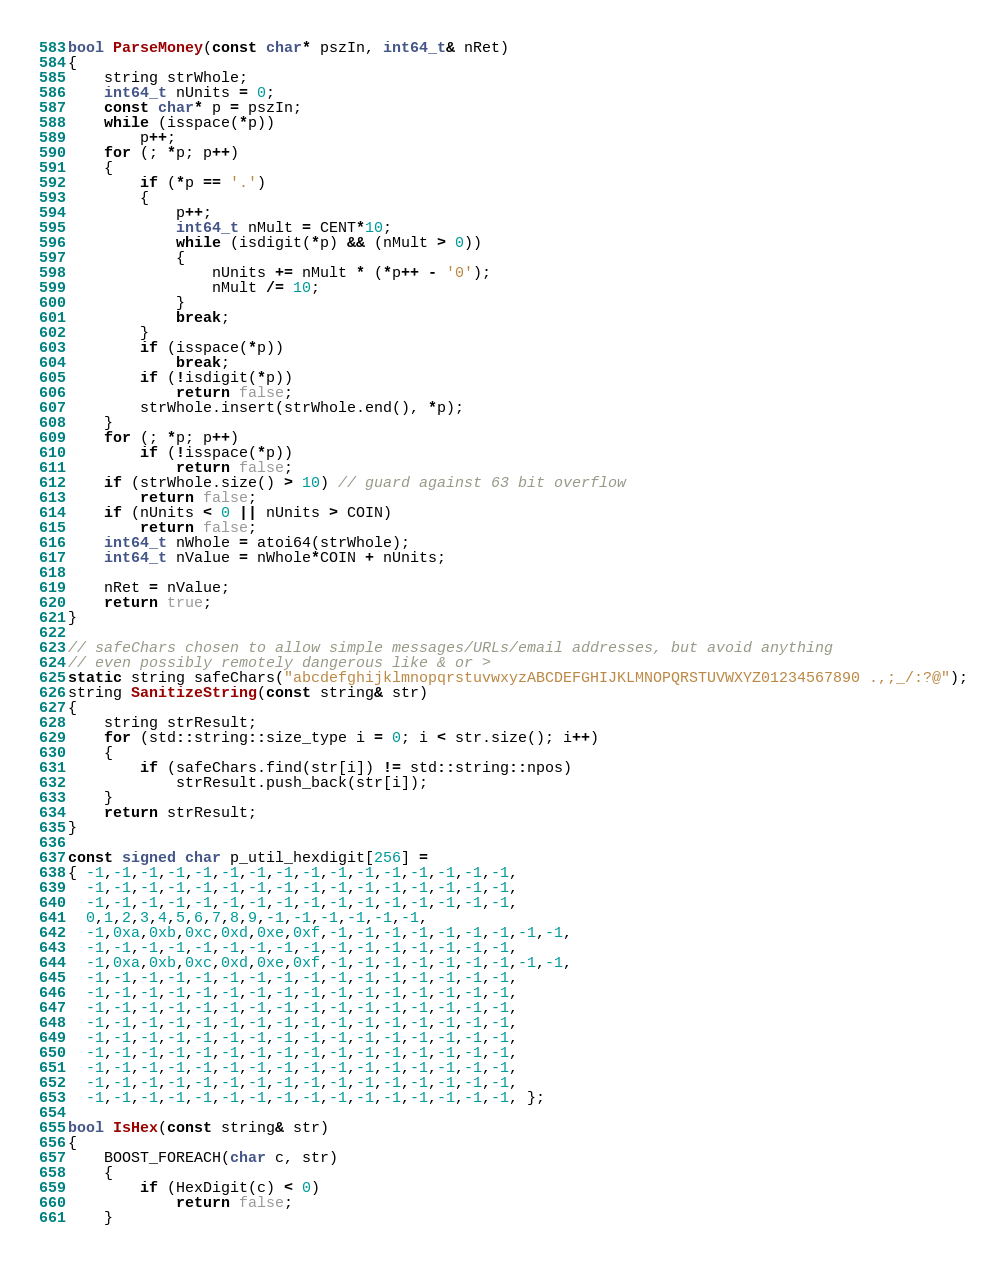Convert code to text. <code><loc_0><loc_0><loc_500><loc_500><_C++_>
bool ParseMoney(const char* pszIn, int64_t& nRet)
{
    string strWhole;
    int64_t nUnits = 0;
    const char* p = pszIn;
    while (isspace(*p))
        p++;
    for (; *p; p++)
    {
        if (*p == '.')
        {
            p++;
            int64_t nMult = CENT*10;
            while (isdigit(*p) && (nMult > 0))
            {
                nUnits += nMult * (*p++ - '0');
                nMult /= 10;
            }
            break;
        }
        if (isspace(*p))
            break;
        if (!isdigit(*p))
            return false;
        strWhole.insert(strWhole.end(), *p);
    }
    for (; *p; p++)
        if (!isspace(*p))
            return false;
    if (strWhole.size() > 10) // guard against 63 bit overflow
        return false;
    if (nUnits < 0 || nUnits > COIN)
        return false;
    int64_t nWhole = atoi64(strWhole);
    int64_t nValue = nWhole*COIN + nUnits;

    nRet = nValue;
    return true;
}

// safeChars chosen to allow simple messages/URLs/email addresses, but avoid anything
// even possibly remotely dangerous like & or >
static string safeChars("abcdefghijklmnopqrstuvwxyzABCDEFGHIJKLMNOPQRSTUVWXYZ01234567890 .,;_/:?@");
string SanitizeString(const string& str)
{
    string strResult;
    for (std::string::size_type i = 0; i < str.size(); i++)
    {
        if (safeChars.find(str[i]) != std::string::npos)
            strResult.push_back(str[i]);
    }
    return strResult;
}

const signed char p_util_hexdigit[256] =
{ -1,-1,-1,-1,-1,-1,-1,-1,-1,-1,-1,-1,-1,-1,-1,-1,
  -1,-1,-1,-1,-1,-1,-1,-1,-1,-1,-1,-1,-1,-1,-1,-1,
  -1,-1,-1,-1,-1,-1,-1,-1,-1,-1,-1,-1,-1,-1,-1,-1,
  0,1,2,3,4,5,6,7,8,9,-1,-1,-1,-1,-1,-1,
  -1,0xa,0xb,0xc,0xd,0xe,0xf,-1,-1,-1,-1,-1,-1,-1,-1,-1,
  -1,-1,-1,-1,-1,-1,-1,-1,-1,-1,-1,-1,-1,-1,-1,-1,
  -1,0xa,0xb,0xc,0xd,0xe,0xf,-1,-1,-1,-1,-1,-1,-1,-1,-1,
  -1,-1,-1,-1,-1,-1,-1,-1,-1,-1,-1,-1,-1,-1,-1,-1,
  -1,-1,-1,-1,-1,-1,-1,-1,-1,-1,-1,-1,-1,-1,-1,-1,
  -1,-1,-1,-1,-1,-1,-1,-1,-1,-1,-1,-1,-1,-1,-1,-1,
  -1,-1,-1,-1,-1,-1,-1,-1,-1,-1,-1,-1,-1,-1,-1,-1,
  -1,-1,-1,-1,-1,-1,-1,-1,-1,-1,-1,-1,-1,-1,-1,-1,
  -1,-1,-1,-1,-1,-1,-1,-1,-1,-1,-1,-1,-1,-1,-1,-1,
  -1,-1,-1,-1,-1,-1,-1,-1,-1,-1,-1,-1,-1,-1,-1,-1,
  -1,-1,-1,-1,-1,-1,-1,-1,-1,-1,-1,-1,-1,-1,-1,-1,
  -1,-1,-1,-1,-1,-1,-1,-1,-1,-1,-1,-1,-1,-1,-1,-1, };

bool IsHex(const string& str)
{
    BOOST_FOREACH(char c, str)
    {
        if (HexDigit(c) < 0)
            return false;
    }</code> 